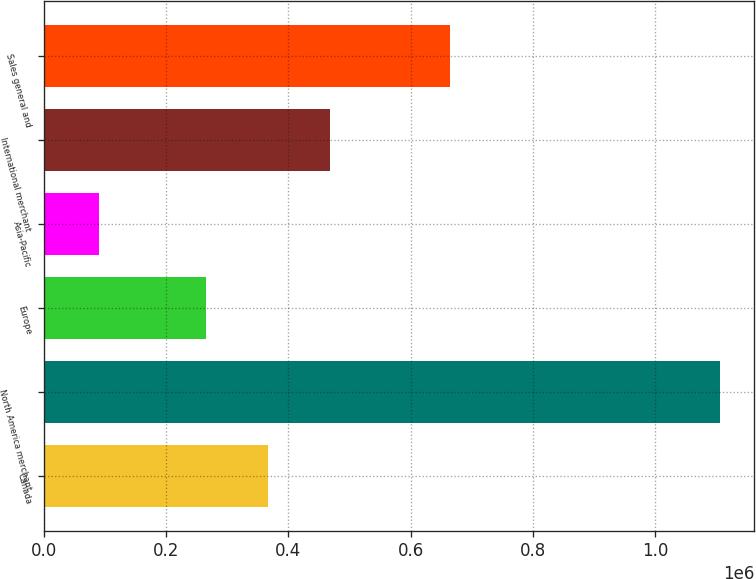<chart> <loc_0><loc_0><loc_500><loc_500><bar_chart><fcel>Canada<fcel>North America merchant<fcel>Europe<fcel>Asia-Pacific<fcel>International merchant<fcel>Sales general and<nl><fcel>366773<fcel>1.10685e+06<fcel>265121<fcel>90334<fcel>468424<fcel>664905<nl></chart> 